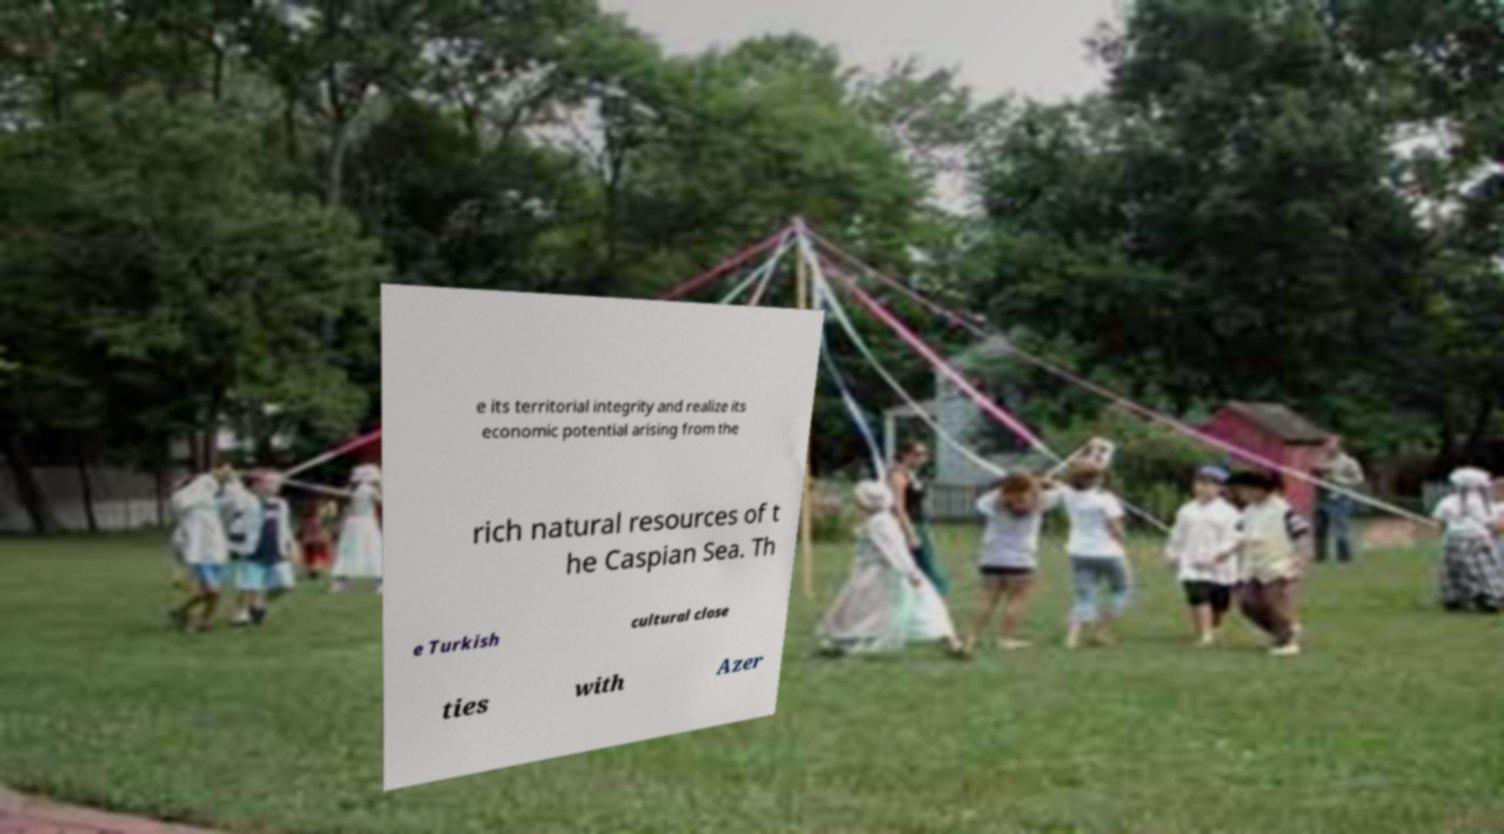Could you extract and type out the text from this image? e its territorial integrity and realize its economic potential arising from the rich natural resources of t he Caspian Sea. Th e Turkish cultural close ties with Azer 